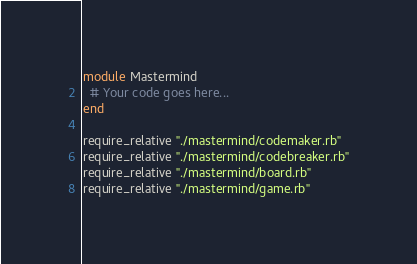<code> <loc_0><loc_0><loc_500><loc_500><_Ruby_>module Mastermind
  # Your code goes here...
end

require_relative "./mastermind/codemaker.rb"
require_relative "./mastermind/codebreaker.rb"
require_relative "./mastermind/board.rb"
require_relative "./mastermind/game.rb"
</code> 